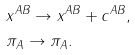<formula> <loc_0><loc_0><loc_500><loc_500>& x ^ { A B } \rightarrow x ^ { A B } + c ^ { A B } , \\ & \pi _ { A } \rightarrow \pi _ { A } .</formula> 